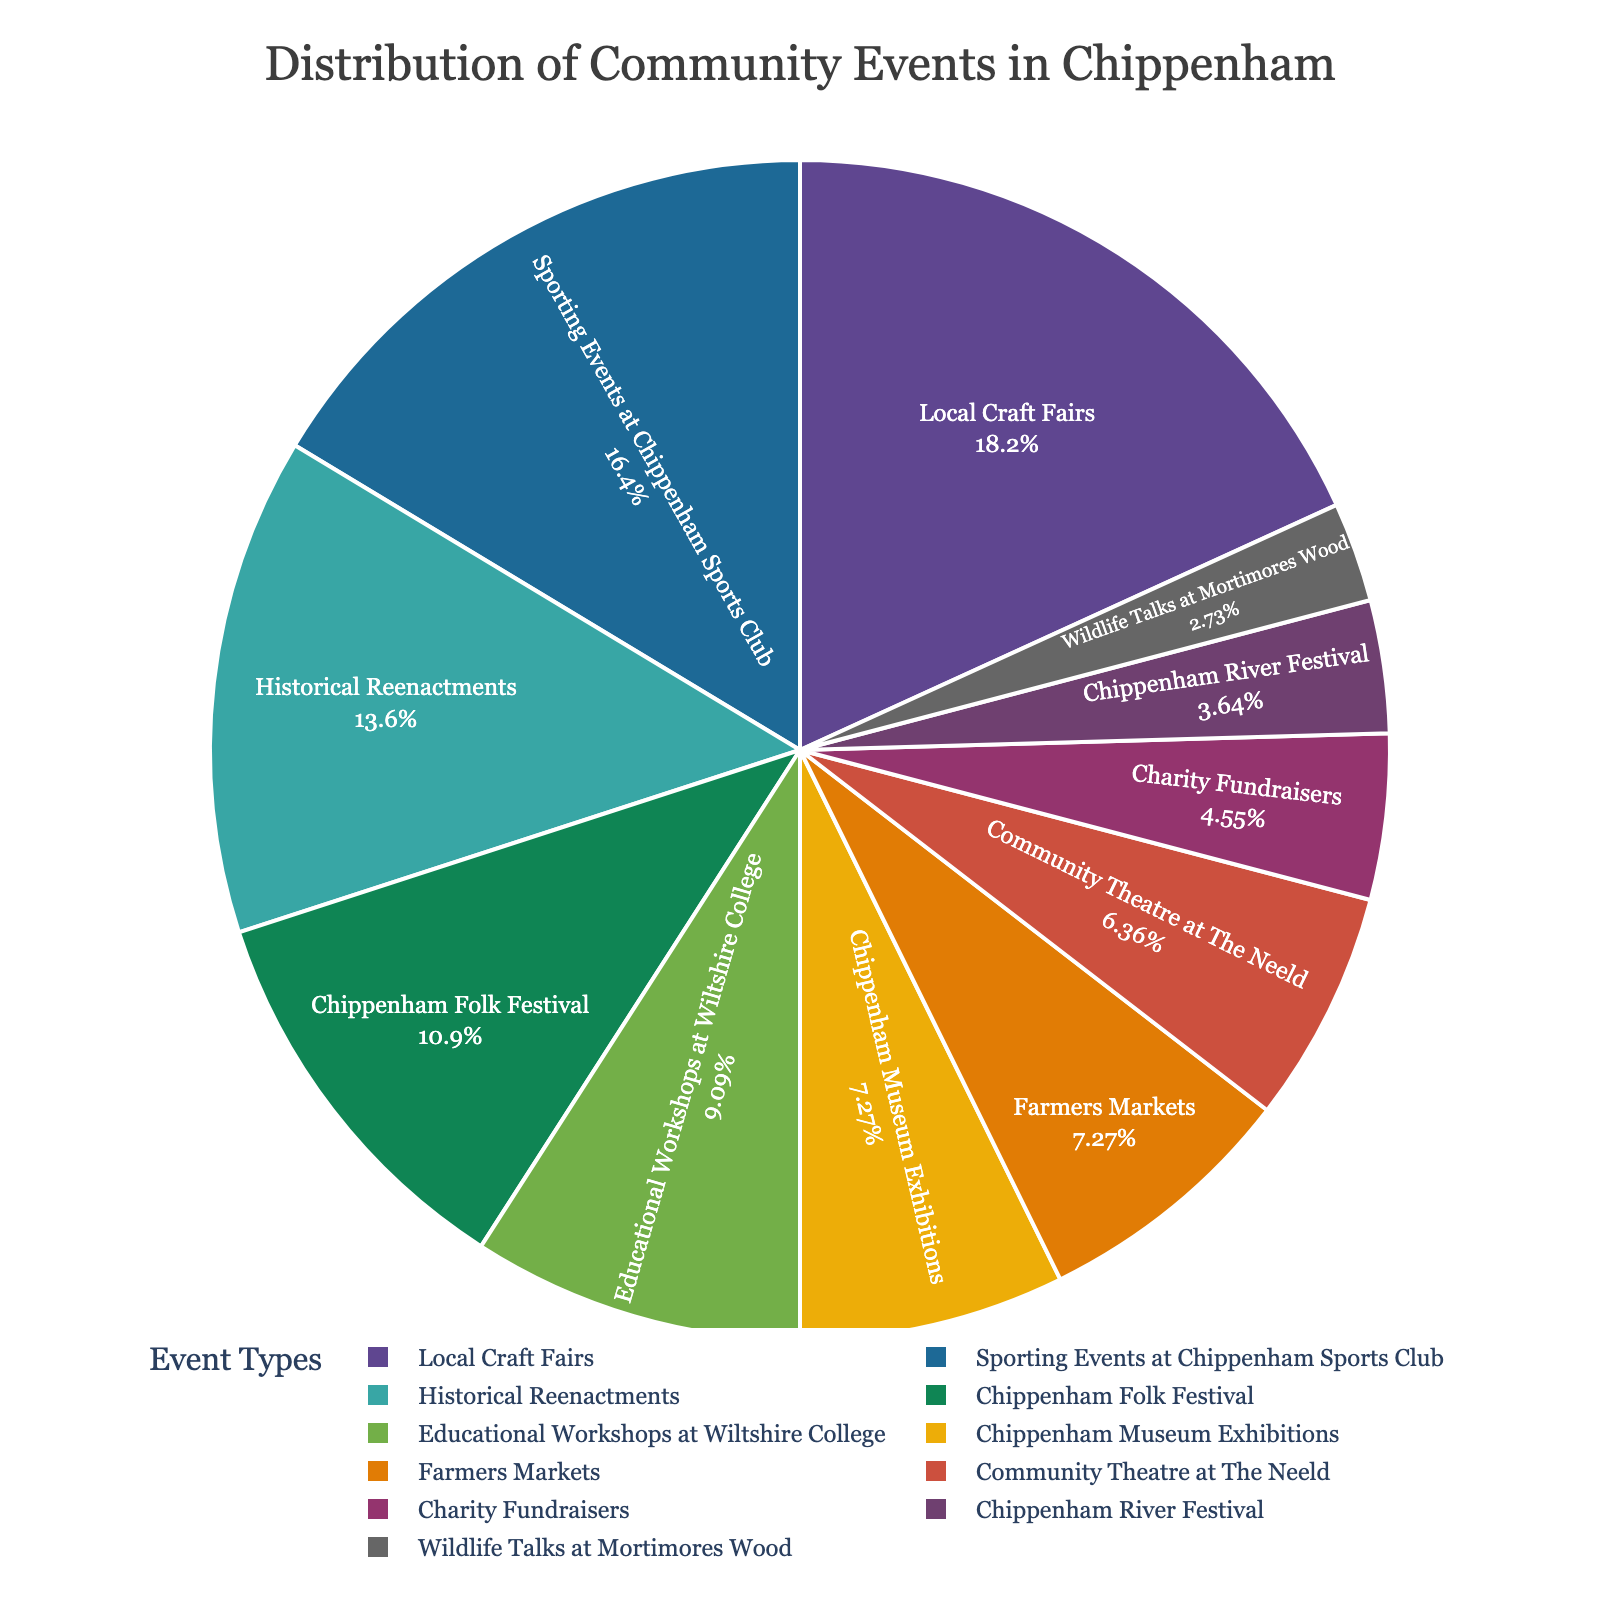Which event type has the largest percentage? The largest percentage can be identified by looking at the largest segment of the pie chart and its corresponding label. In the chart, "Local Craft Fairs" has the largest segment.
Answer: Local Craft Fairs How much larger is the percentage of Local Craft Fairs compared to Chippenham Folk Festival? First, find the percentages for both events: Local Craft Fairs (20%) and Chippenham Folk Festival (12%). Then subtract the smaller percentage from the larger one: 20% - 12% = 8%.
Answer: 8% What is the combined percentage of Historical Reenactments and Chippenham River Festival? Sum the percentages of the two events: Historical Reenactments (15%) + Chippenham River Festival (4%) = 19%.
Answer: 19% Which event type has the lowest percentage? The smallest segment in the pie chart corresponds to "Wildlife Talks at Mortimores Wood," showing it has the lowest percentage.
Answer: Wildlife Talks at Mortimores Wood Compare the percentages of Sporting Events at Chippenham Sports Club and Educational Workshops at Wiltshire College. Which one has a higher percentage? Sporting Events at Chippenham Sports Club has a percentage of 18%, while Educational Workshops at Wiltshire College have 10%. Since 18% is greater than 10%, Sporting Events are higher.
Answer: Sporting Events at Chippenham Sports Club What is the percentage difference between Chippenham Museum Exhibitions and Community Theatre at The Neeld? Find the percentages: Chippenham Museum Exhibitions (8%) and Community Theatre at The Neeld (7%). Then calculate the difference: 8% - 7% = 1%.
Answer: 1% Combine the percentages of the three smallest event types and state the total. Identify the three smallest percentages: Chippenham River Festival (4%), Wildlife Talks at Mortimores Wood (3%), and Charity Fundraisers (5%). Sum them up: 4% + 3% + 5% = 12%.
Answer: 12% Are there more than one event type with exactly 8%? If yes, name them. By examining the pie chart, there are two event types with exactly 8%: Chippenham Museum Exhibitions and Farmers Markets.
Answer: Yes, Chippenham Museum Exhibitions and Farmers Markets Which visual element helps in quickly identifying the percentages of each event type? The text inside each segment shows the percentage along with the label, which helps in quickly identifying the percentages.
Answer: Text inside segments 